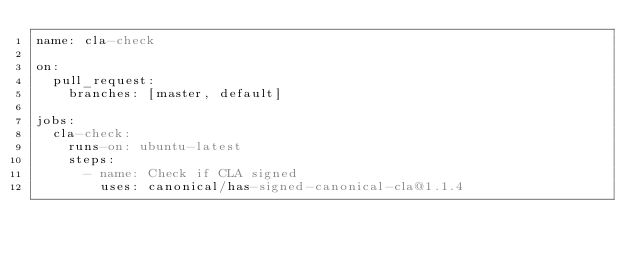<code> <loc_0><loc_0><loc_500><loc_500><_YAML_>name: cla-check

on:
  pull_request:
    branches: [master, default]

jobs:
  cla-check:
    runs-on: ubuntu-latest
    steps:
      - name: Check if CLA signed
        uses: canonical/has-signed-canonical-cla@1.1.4
</code> 